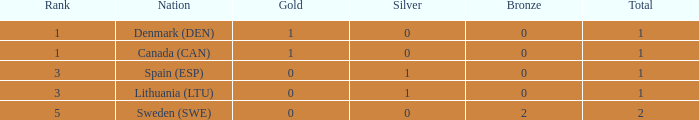What is the number of gold medals for Lithuania (ltu), when the total is more than 1? None. 